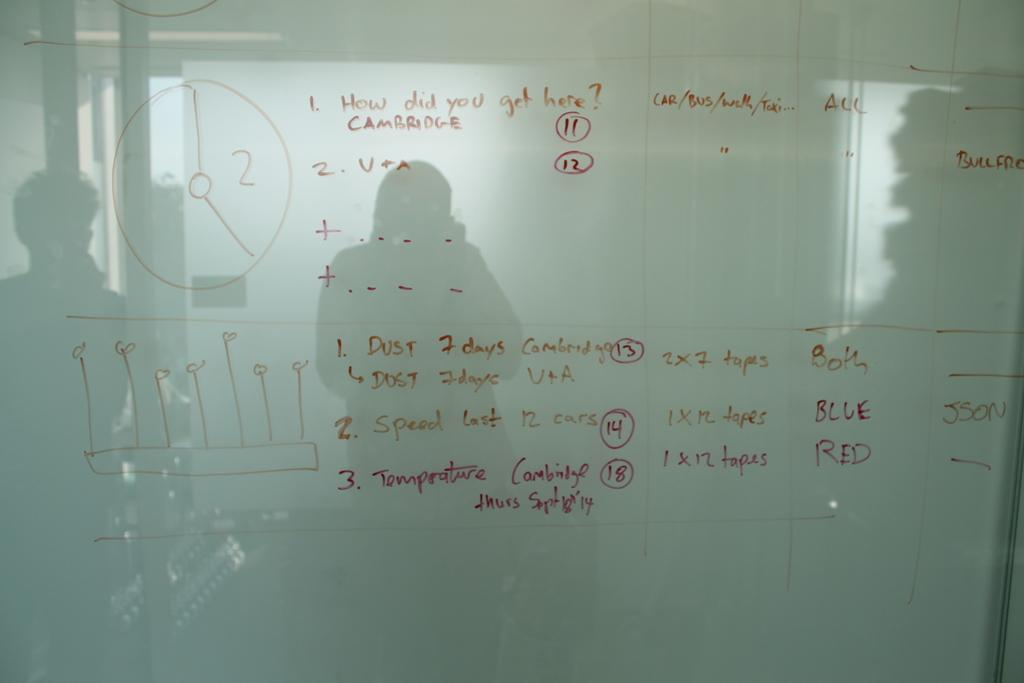<image>
Share a concise interpretation of the image provided. A glass board has the words dust, screen, and temperature on it. 